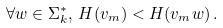Convert formula to latex. <formula><loc_0><loc_0><loc_500><loc_500>\forall w \in \Sigma _ { k } ^ { * } , \, H ( v _ { m } ) < H ( v _ { m } w ) \, .</formula> 